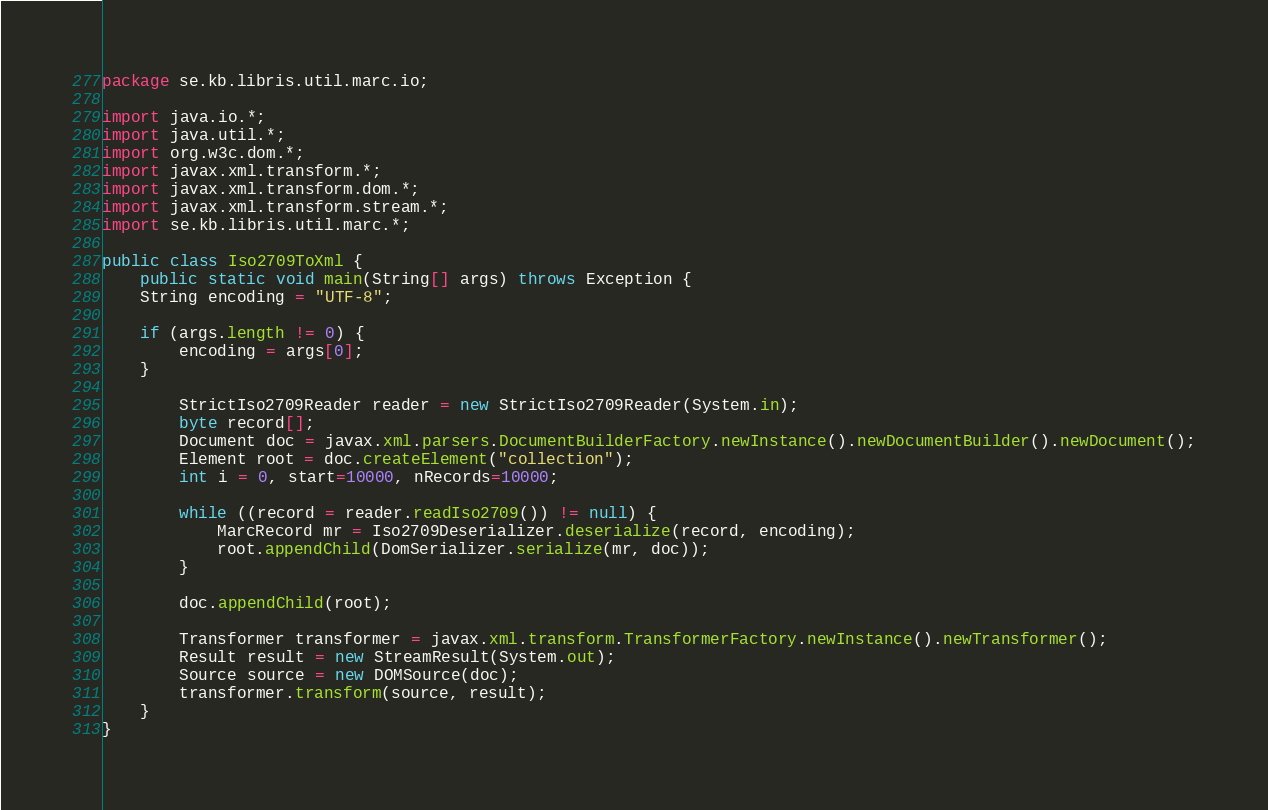<code> <loc_0><loc_0><loc_500><loc_500><_Java_>package se.kb.libris.util.marc.io;

import java.io.*;
import java.util.*;
import org.w3c.dom.*;
import javax.xml.transform.*;
import javax.xml.transform.dom.*;
import javax.xml.transform.stream.*;
import se.kb.libris.util.marc.*;

public class Iso2709ToXml {
    public static void main(String[] args) throws Exception {
	String encoding = "UTF-8";

	if (args.length != 0) {
	    encoding = args[0];
	}

        StrictIso2709Reader reader = new StrictIso2709Reader(System.in);
        byte record[];
        Document doc = javax.xml.parsers.DocumentBuilderFactory.newInstance().newDocumentBuilder().newDocument();
        Element root = doc.createElement("collection");
        int i = 0, start=10000, nRecords=10000;
        
        while ((record = reader.readIso2709()) != null) {
            MarcRecord mr = Iso2709Deserializer.deserialize(record, encoding);
            root.appendChild(DomSerializer.serialize(mr, doc));            
        }       
        
        doc.appendChild(root);

        Transformer transformer = javax.xml.transform.TransformerFactory.newInstance().newTransformer();
        Result result = new StreamResult(System.out);
        Source source = new DOMSource(doc);
        transformer.transform(source, result);
    }   
}
</code> 